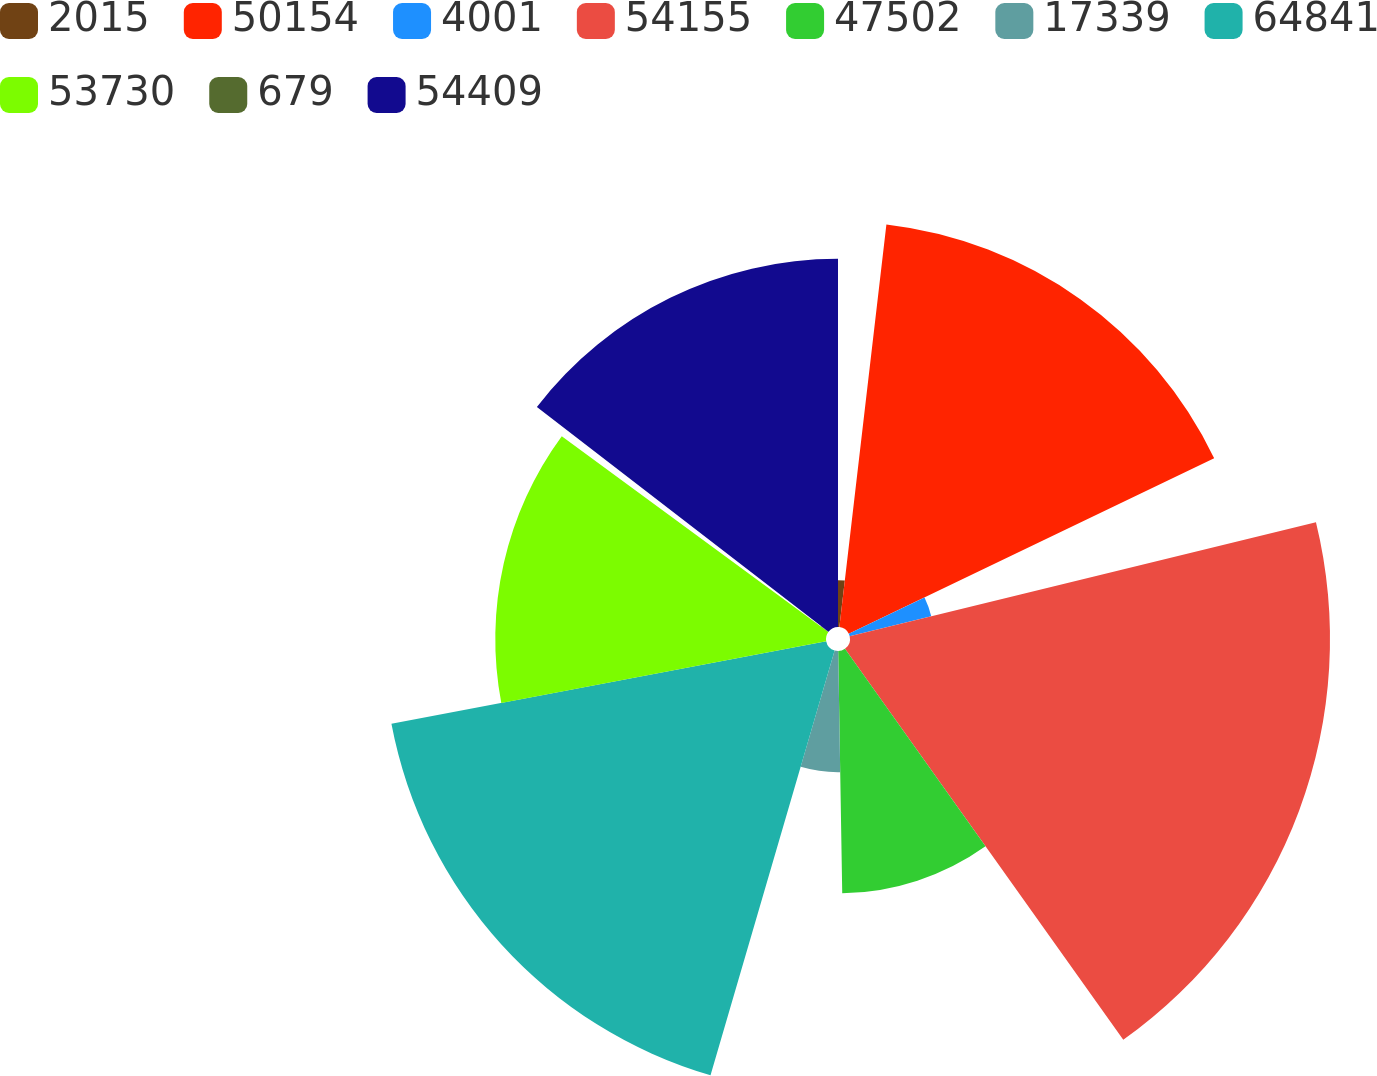Convert chart. <chart><loc_0><loc_0><loc_500><loc_500><pie_chart><fcel>2015<fcel>50154<fcel>4001<fcel>54155<fcel>47502<fcel>17339<fcel>64841<fcel>53730<fcel>679<fcel>54409<nl><fcel>1.85%<fcel>16.02%<fcel>3.32%<fcel>18.97%<fcel>9.58%<fcel>4.79%<fcel>17.49%<fcel>13.07%<fcel>0.37%<fcel>14.55%<nl></chart> 